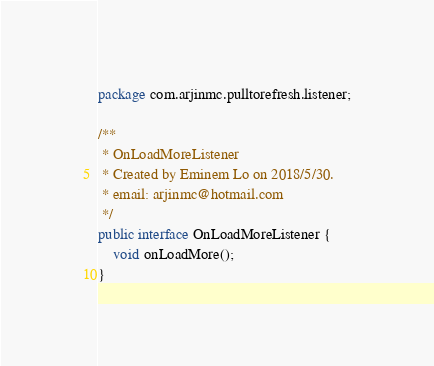Convert code to text. <code><loc_0><loc_0><loc_500><loc_500><_Java_>package com.arjinmc.pulltorefresh.listener;

/**
 * OnLoadMoreListener
 * Created by Eminem Lo on 2018/5/30.
 * email: arjinmc@hotmail.com
 */
public interface OnLoadMoreListener {
    void onLoadMore();
}
</code> 